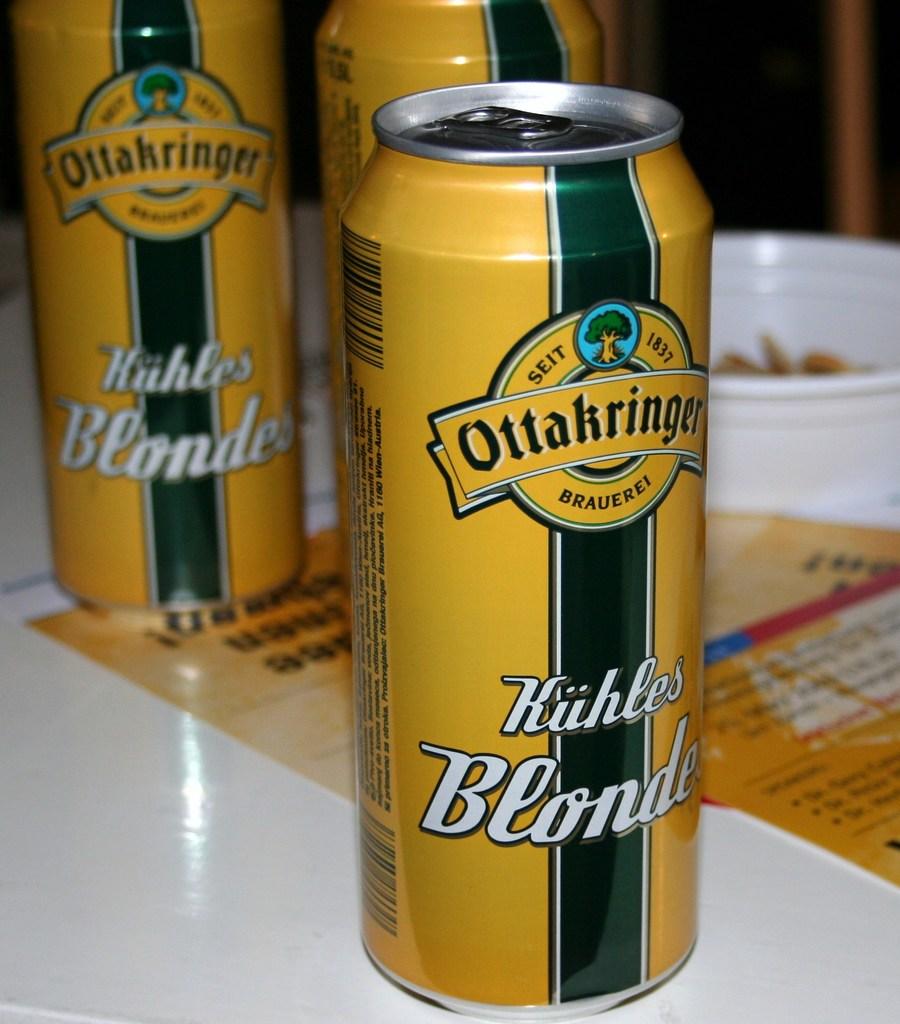Is ottakringer a beer?
Provide a succinct answer. Yes. 